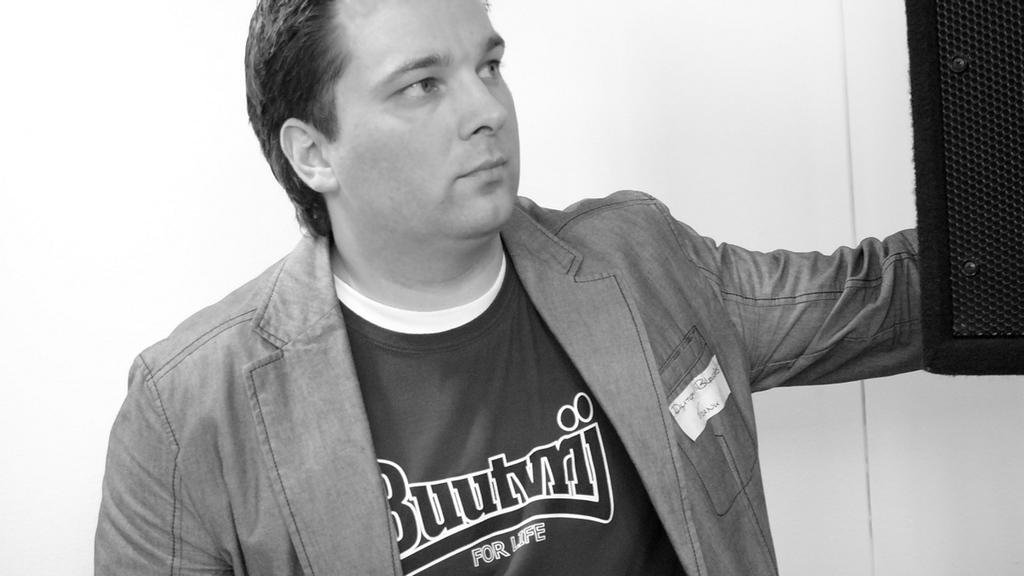<image>
Relay a brief, clear account of the picture shown. Man wearing a shirt that says "Buutvrij" on it. 